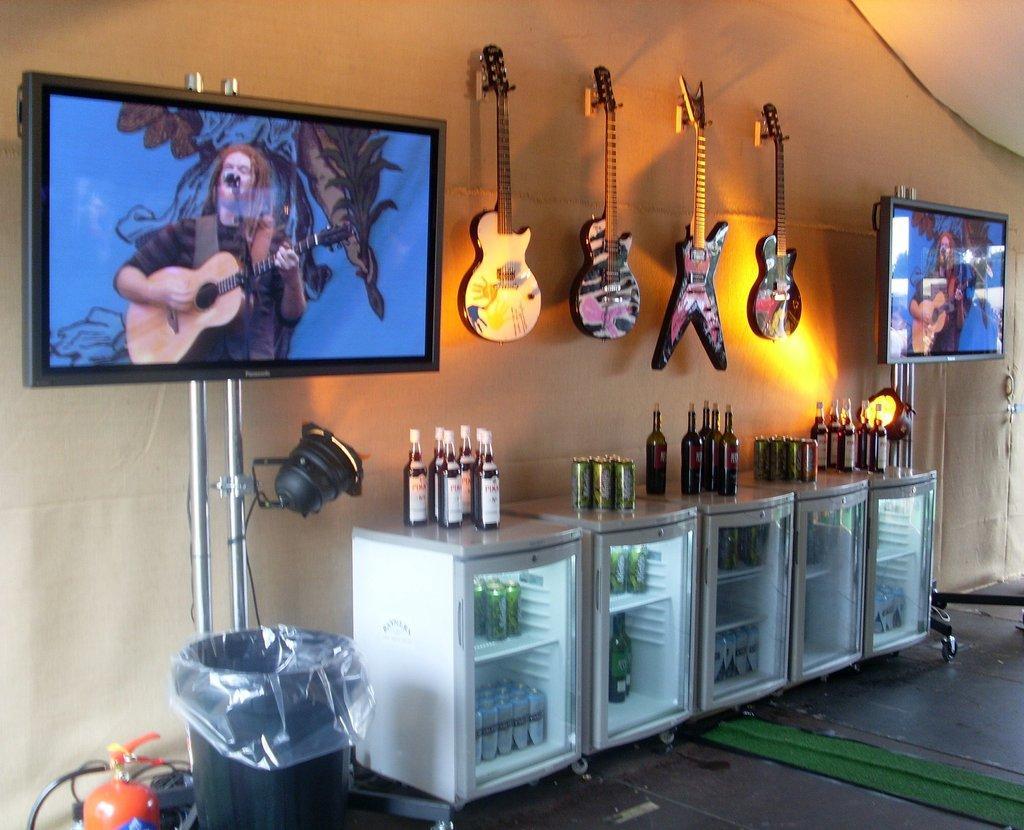Describe this image in one or two sentences. In this picture we can see two screens. In this screen there is a person standing and playing a guitar. These are the guitars. There is a wall, and this is the floor. Here we can see some bottles in the refrigerator. This is the bin. 